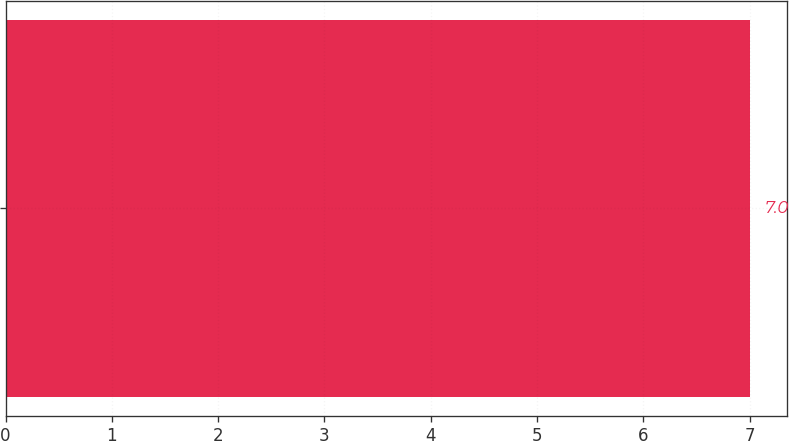Convert chart. <chart><loc_0><loc_0><loc_500><loc_500><bar_chart><ecel><nl><fcel>7<nl></chart> 